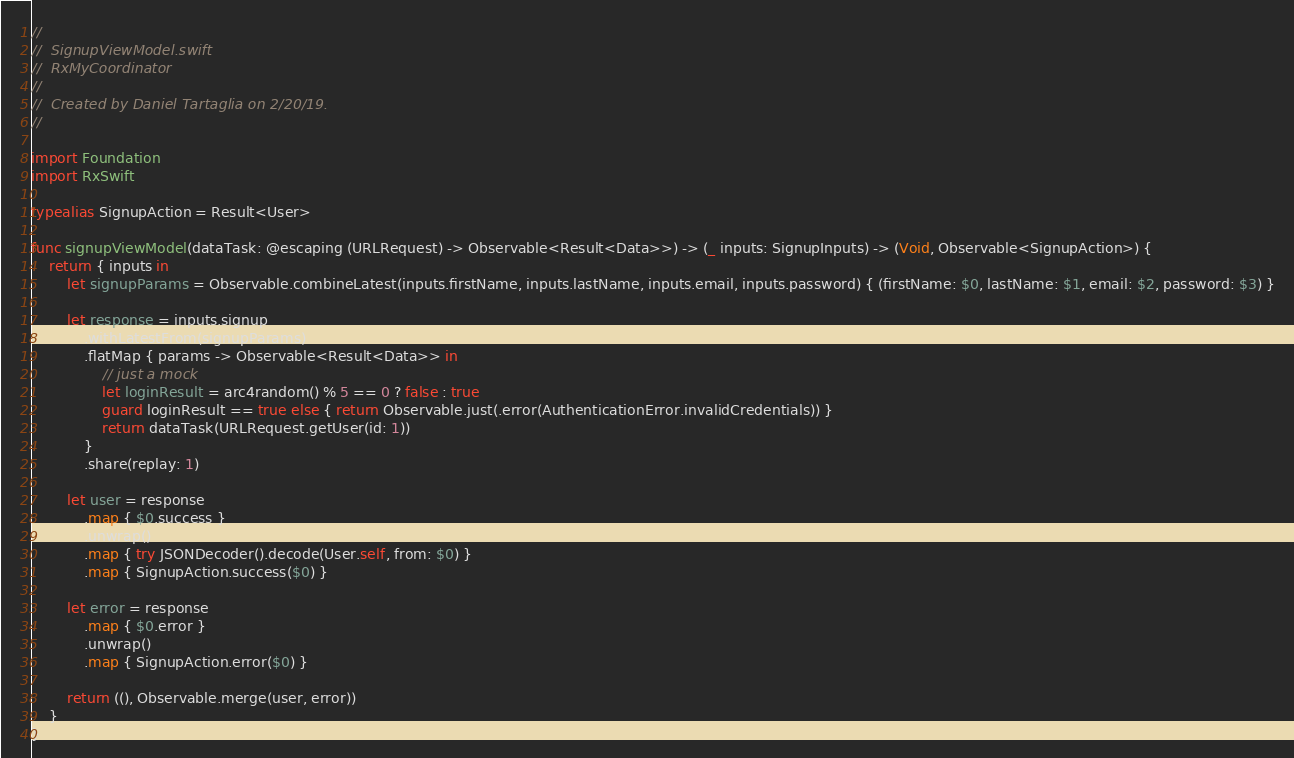<code> <loc_0><loc_0><loc_500><loc_500><_Swift_>//
//  SignupViewModel.swift
//  RxMyCoordinator
//
//  Created by Daniel Tartaglia on 2/20/19.
//

import Foundation
import RxSwift

typealias SignupAction = Result<User>

func signupViewModel(dataTask: @escaping (URLRequest) -> Observable<Result<Data>>) -> (_ inputs: SignupInputs) -> (Void, Observable<SignupAction>) {
	return { inputs in
		let signupParams = Observable.combineLatest(inputs.firstName, inputs.lastName, inputs.email, inputs.password) { (firstName: $0, lastName: $1, email: $2, password: $3) }

		let response = inputs.signup
			.withLatestFrom(signupParams)
			.flatMap { params -> Observable<Result<Data>> in
				// just a mock
				let loginResult = arc4random() % 5 == 0 ? false : true
				guard loginResult == true else { return Observable.just(.error(AuthenticationError.invalidCredentials)) }
				return dataTask(URLRequest.getUser(id: 1))
			}
			.share(replay: 1)

		let user = response
			.map { $0.success }
			.unwrap()
			.map { try JSONDecoder().decode(User.self, from: $0) }
			.map { SignupAction.success($0) }

		let error = response
			.map { $0.error }
			.unwrap()
			.map { SignupAction.error($0) }

		return ((), Observable.merge(user, error))
	}
}

</code> 